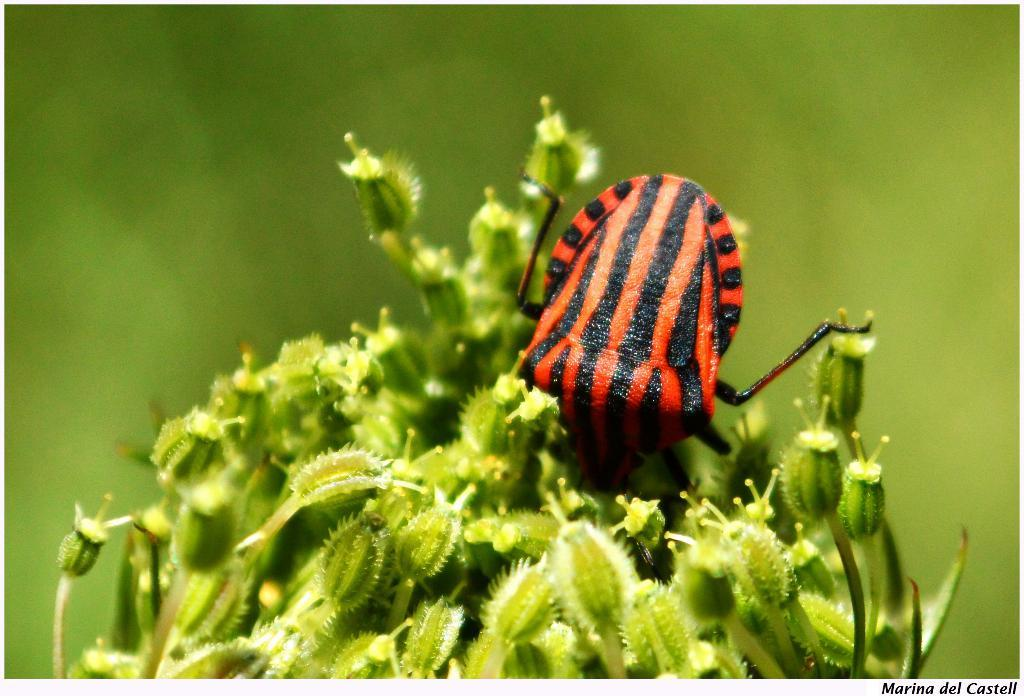What is present on the plant in the image? There is an insect on a plant in the image. What color is the background of the image? The background of the image is green. What type of letter is being delivered by the insect in the image? There is no letter present in the image, and the insect is not delivering anything. 